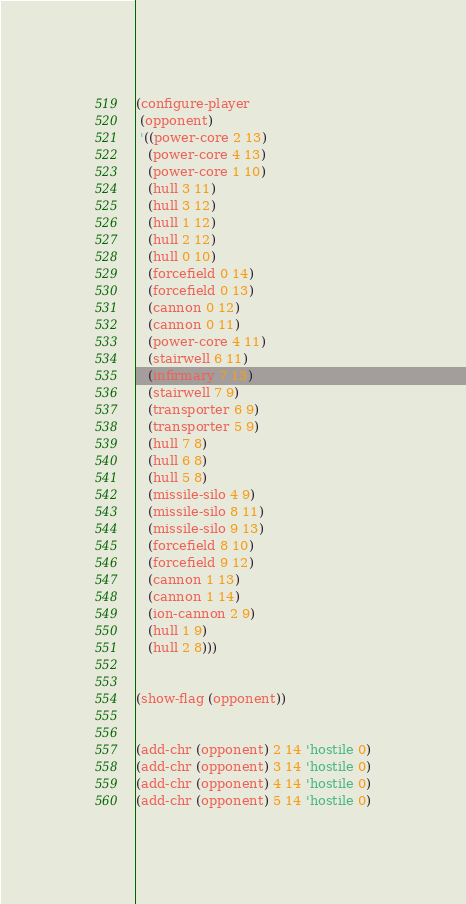<code> <loc_0><loc_0><loc_500><loc_500><_Lisp_>(configure-player
 (opponent)
 '((power-core 2 13)
   (power-core 4 13)
   (power-core 1 10)
   (hull 3 11)
   (hull 3 12)
   (hull 1 12)
   (hull 2 12)
   (hull 0 10)
   (forcefield 0 14)
   (forcefield 0 13)
   (cannon 0 12)
   (cannon 0 11)
   (power-core 4 11)
   (stairwell 6 11)
   (infirmary 7 13)
   (stairwell 7 9)
   (transporter 6 9)
   (transporter 5 9)
   (hull 7 8)
   (hull 6 8)
   (hull 5 8)
   (missile-silo 4 9)
   (missile-silo 8 11)
   (missile-silo 9 13)
   (forcefield 8 10)
   (forcefield 9 12)
   (cannon 1 13)
   (cannon 1 14)
   (ion-cannon 2 9)
   (hull 1 9)
   (hull 2 8)))


(show-flag (opponent))


(add-chr (opponent) 2 14 'hostile 0)
(add-chr (opponent) 3 14 'hostile 0)
(add-chr (opponent) 4 14 'hostile 0)
(add-chr (opponent) 5 14 'hostile 0)
</code> 